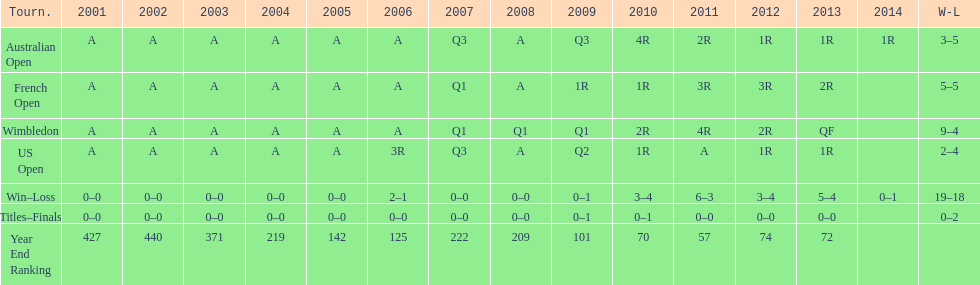Which year end ranking was higher, 2004 or 2011? 2011. 